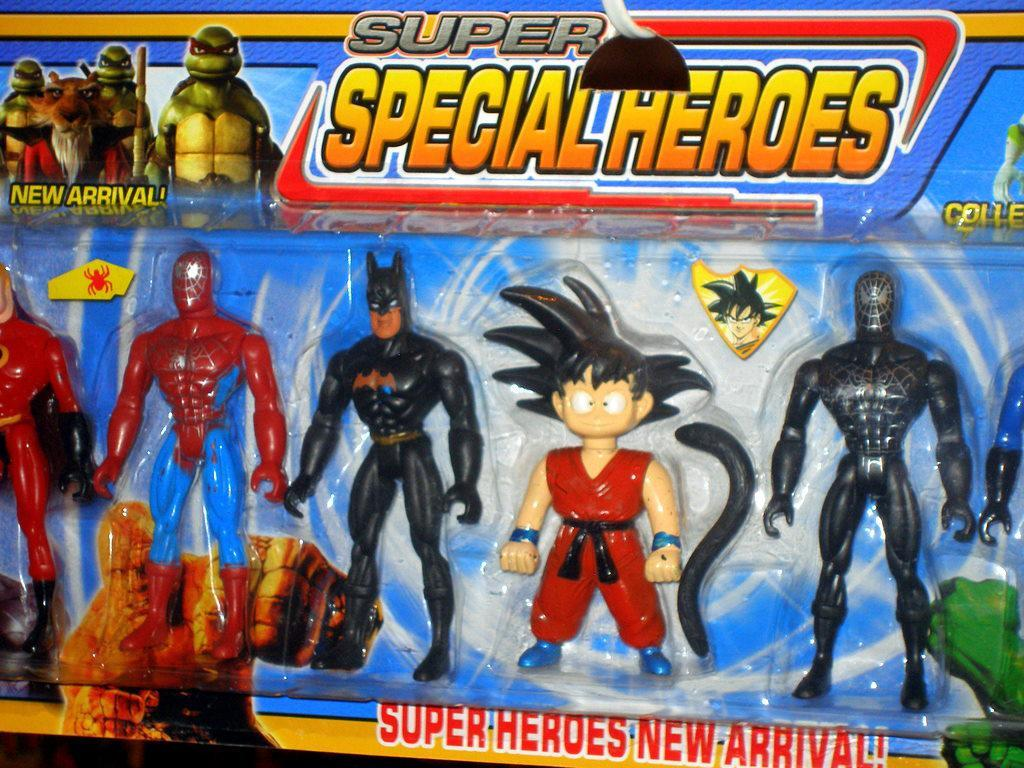<image>
Create a compact narrative representing the image presented. collection of Super Special Heroes for kids to play with. 